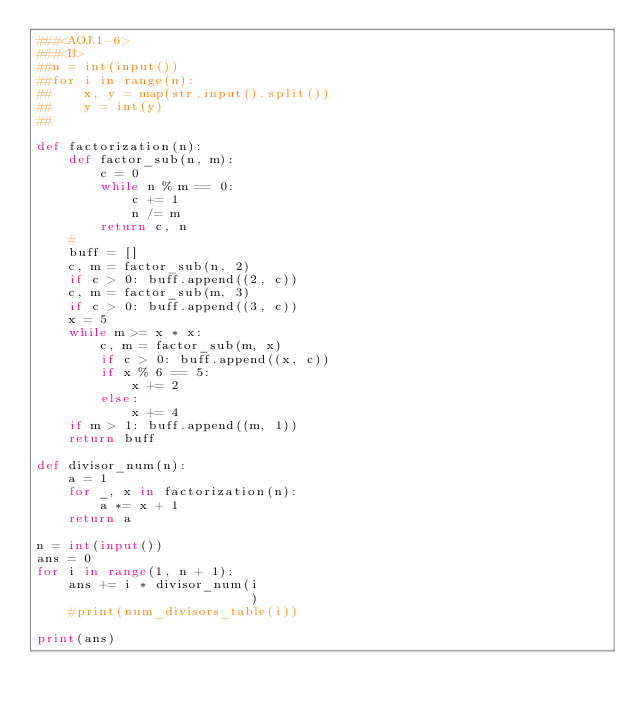Convert code to text. <code><loc_0><loc_0><loc_500><loc_500><_Python_>###<AOJ.1-6>
###<B>
##n = int(input())
##for i in range(n):
##    x, y = map(str,input().split())
##    y = int(y)
##    

def factorization(n):
    def factor_sub(n, m):
        c = 0
        while n % m == 0:
            c += 1
            n /= m
        return c, n
    #
    buff = []
    c, m = factor_sub(n, 2)
    if c > 0: buff.append((2, c))
    c, m = factor_sub(m, 3)
    if c > 0: buff.append((3, c))
    x = 5
    while m >= x * x:
        c, m = factor_sub(m, x)
        if c > 0: buff.append((x, c))
        if x % 6 == 5:
            x += 2
        else:
            x += 4
    if m > 1: buff.append((m, 1))
    return buff

def divisor_num(n):
    a = 1
    for _, x in factorization(n):
        a *= x + 1
    return a

n = int(input())
ans = 0
for i in range(1, n + 1):
    ans += i * divisor_num(i
                           )
    #print(num_divisors_table(i))

print(ans)
    


</code> 